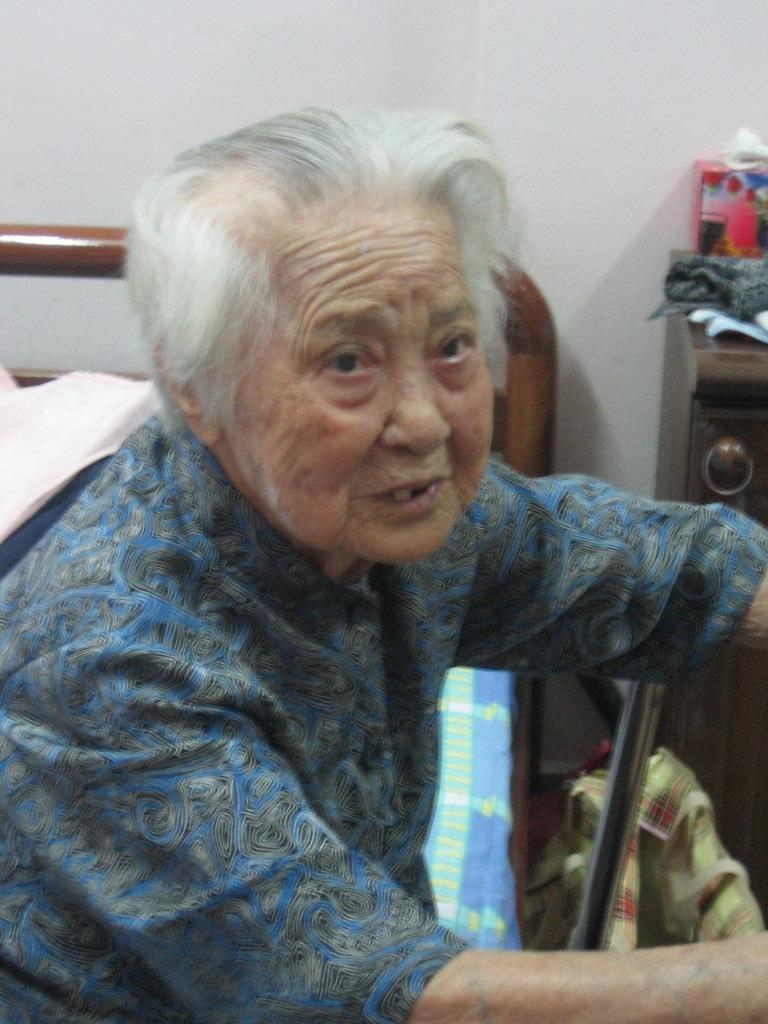What is the position of the old person in the image? There is an old person sitting on the bed in the image. What can be seen in the background of the image? There is a wall in the background of the image. Where is the cupboard located in the image? The cupboard is on the right side of the image. What items are on the cupboard? Clothes and a box are present on the cupboard. How does the old person's toe contribute to the debt in the image? There is no mention of debt or the old person's toe in the image, so it cannot be determined how they might be related. 